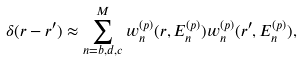<formula> <loc_0><loc_0><loc_500><loc_500>\delta ( r - r ^ { \prime } ) \approx \sum _ { n = b , d , c } ^ { M } { w ^ { ( p ) } _ { n } ( r , E ^ { ( p ) } _ { n } ) } w ^ { ( p ) } _ { n } ( r ^ { \prime } , E ^ { ( p ) } _ { n } ) ,</formula> 